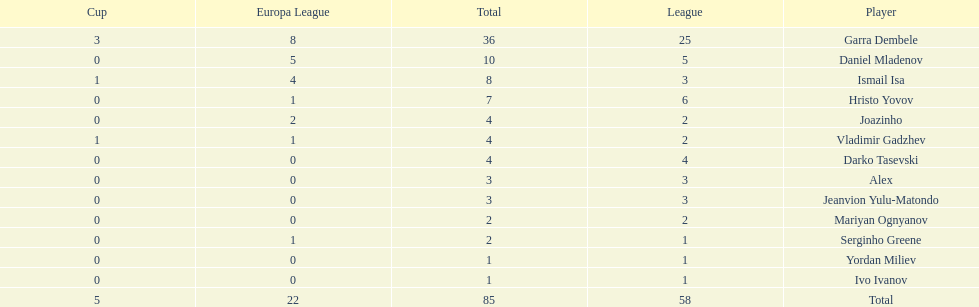Who had the most goal scores? Garra Dembele. 